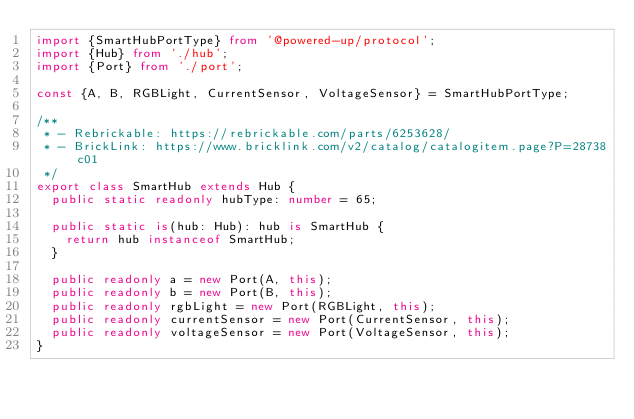<code> <loc_0><loc_0><loc_500><loc_500><_TypeScript_>import {SmartHubPortType} from '@powered-up/protocol';
import {Hub} from './hub';
import {Port} from './port';

const {A, B, RGBLight, CurrentSensor, VoltageSensor} = SmartHubPortType;

/**
 * - Rebrickable: https://rebrickable.com/parts/6253628/
 * - BrickLink: https://www.bricklink.com/v2/catalog/catalogitem.page?P=28738c01
 */
export class SmartHub extends Hub {
  public static readonly hubType: number = 65;

  public static is(hub: Hub): hub is SmartHub {
    return hub instanceof SmartHub;
  }

  public readonly a = new Port(A, this);
  public readonly b = new Port(B, this);
  public readonly rgbLight = new Port(RGBLight, this);
  public readonly currentSensor = new Port(CurrentSensor, this);
  public readonly voltageSensor = new Port(VoltageSensor, this);
}
</code> 